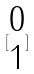Convert formula to latex. <formula><loc_0><loc_0><loc_500><loc_500>[ \begin{matrix} 0 \\ 1 \end{matrix} ]</formula> 